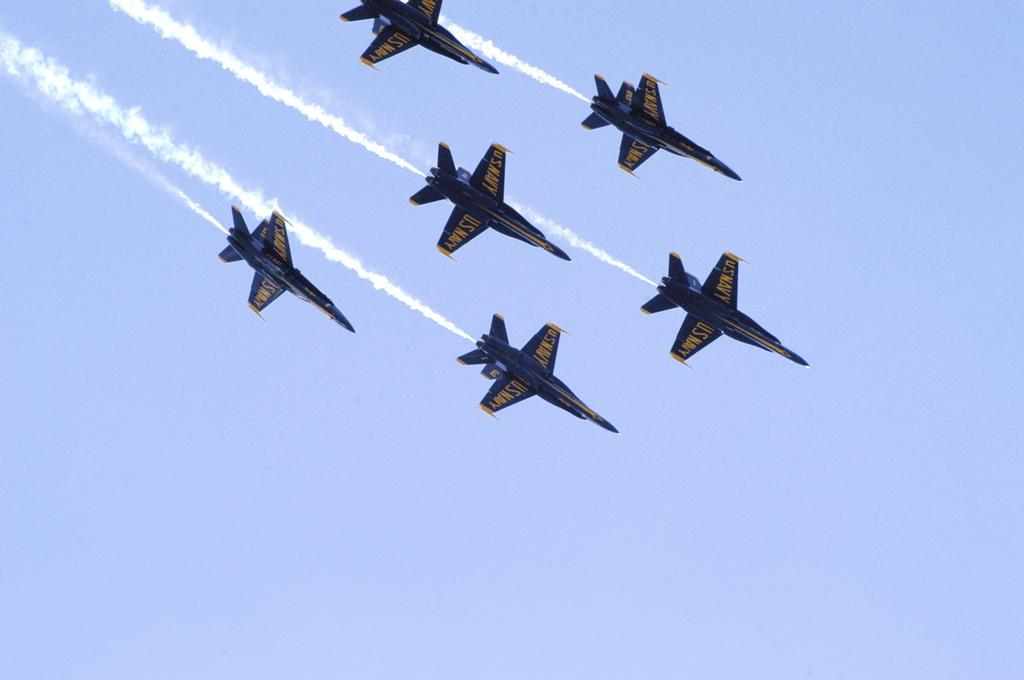What is the main subject of the image? The main subject of the image is aircrafts. What colors are the aircrafts in the image? The aircrafts are blue and yellow in color. What are the aircrafts doing in the image? The aircrafts are flying in the air. What can be seen behind the aircrafts in the image? There is smoke visible behind the aircrafts. What is visible in the background of the image? The sky is visible in the background of the image. What type of steel is used to construct the ball in the image? There is no ball present in the image; it features aircrafts flying in the air. What kind of picture is hanging on the wall in the image? There is no wall or picture visible in the image; it focuses on aircrafts flying in the air. 